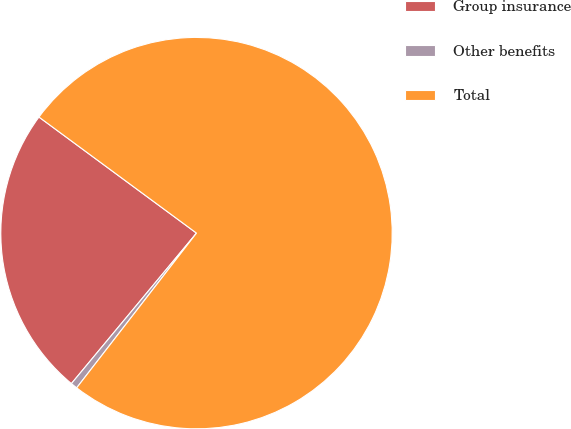<chart> <loc_0><loc_0><loc_500><loc_500><pie_chart><fcel>Group insurance<fcel>Other benefits<fcel>Total<nl><fcel>24.07%<fcel>0.55%<fcel>75.39%<nl></chart> 